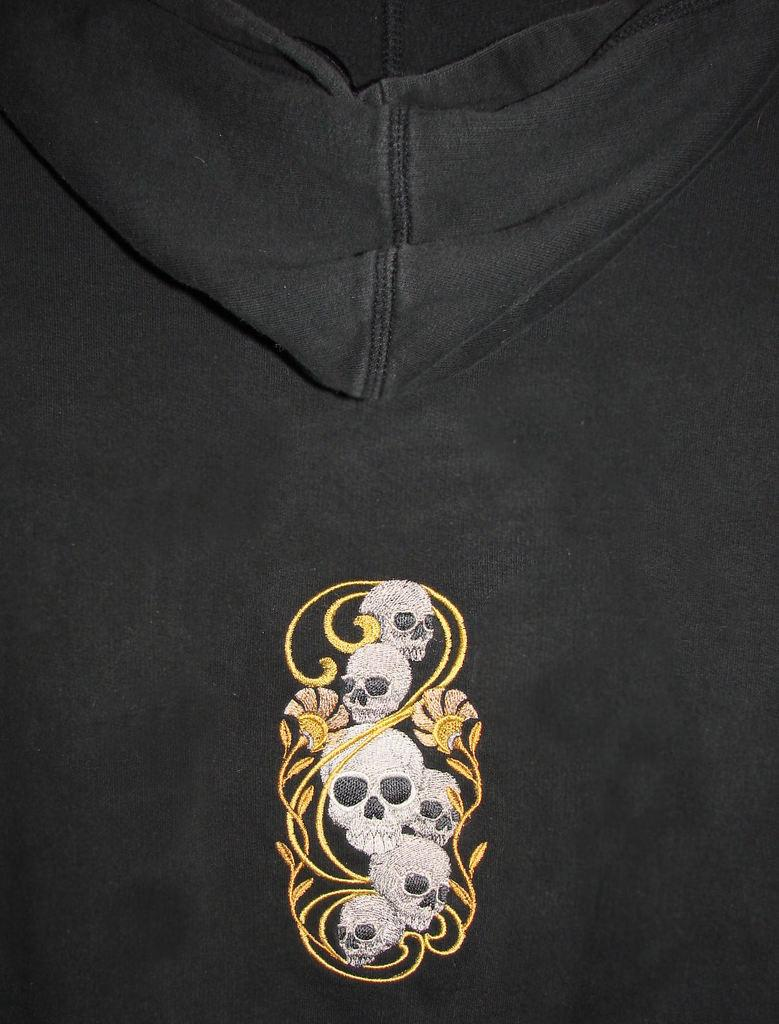What design can be seen on the t-shirt in the image? There is a skull design on the t-shirt in the image. What type of joke is being told by the skull on the t-shirt in the image? There is no indication in the image that the skull design is telling a joke, as it is a static design on a t-shirt. 